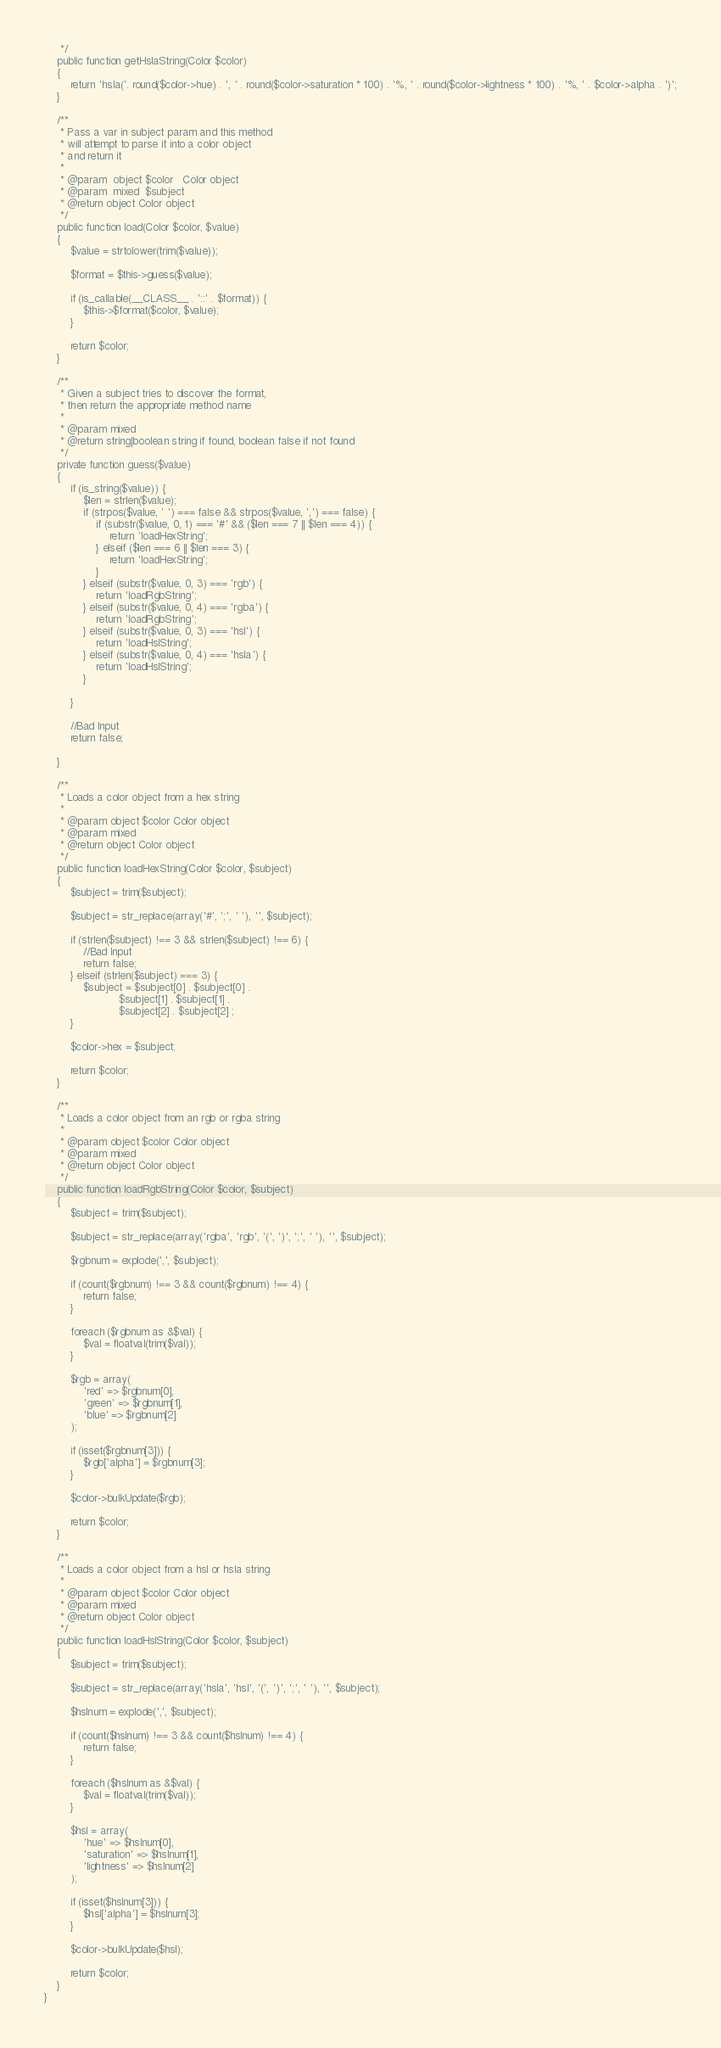Convert code to text. <code><loc_0><loc_0><loc_500><loc_500><_PHP_>     */
    public function getHslaString(Color $color)
    {
        return 'hsla('. round($color->hue) . ', ' . round($color->saturation * 100) . '%, ' . round($color->lightness * 100) . '%, ' . $color->alpha . ')';
    }

    /**
     * Pass a var in subject param and this method
     * will attempt to parse it into a color object
     * and return it
     *
     * @param  object $color   Color object
     * @param  mixed  $subject
     * @return object Color object
     */
    public function load(Color $color, $value)
    {
        $value = strtolower(trim($value));

        $format = $this->guess($value);

        if (is_callable(__CLASS__ . '::' . $format)) {
            $this->$format($color, $value);
        }

        return $color;
    }

    /**
     * Given a subject tries to discover the format,
     * then return the appropriate method name
     *
     * @param mixed
     * @return string|boolean string if found, boolean false if not found
     */
    private function guess($value)
    {
        if (is_string($value)) {
            $len = strlen($value);
            if (strpos($value, ' ') === false && strpos($value, ',') === false) {
                if (substr($value, 0, 1) === '#' && ($len === 7 || $len === 4)) {
                    return 'loadHexString';
                } elseif ($len === 6 || $len === 3) {
                    return 'loadHexString';
                }
            } elseif (substr($value, 0, 3) === 'rgb') {
                return 'loadRgbString';
            } elseif (substr($value, 0, 4) === 'rgba') {
                return 'loadRgbString';
            } elseif (substr($value, 0, 3) === 'hsl') {
                return 'loadHslString';
            } elseif (substr($value, 0, 4) === 'hsla') {
                return 'loadHslString';
            }

        }

        //Bad Input
        return false;

    }

    /**
     * Loads a color object from a hex string
     *
     * @param object $color Color object
     * @param mixed
     * @return object Color object
     */
    public function loadHexString(Color $color, $subject)
    {
        $subject = trim($subject);

        $subject = str_replace(array('#', ';', ' '), '', $subject);

        if (strlen($subject) !== 3 && strlen($subject) !== 6) {
            //Bad Input
            return false;
        } elseif (strlen($subject) === 3) {
            $subject = $subject[0] . $subject[0] .
                       $subject[1] . $subject[1] .
                       $subject[2] . $subject[2] ;
        }

        $color->hex = $subject;

        return $color;
    }

    /**
     * Loads a color object from an rgb or rgba string
     *
     * @param object $color Color object
     * @param mixed
     * @return object Color object
     */
    public function loadRgbString(Color $color, $subject)
    {
        $subject = trim($subject);

        $subject = str_replace(array('rgba', 'rgb', '(', ')', ';', ' '), '', $subject);

        $rgbnum = explode(',', $subject);

        if (count($rgbnum) !== 3 && count($rgbnum) !== 4) {
            return false;
        }

        foreach ($rgbnum as &$val) {
            $val = floatval(trim($val));
        }

        $rgb = array(
            'red' => $rgbnum[0],
            'green' => $rgbnum[1],
            'blue' => $rgbnum[2]
        );

        if (isset($rgbnum[3])) {
            $rgb['alpha'] = $rgbnum[3];
        }

        $color->bulkUpdate($rgb);

        return $color;
    }

    /**
     * Loads a color object from a hsl or hsla string
     *
     * @param object $color Color object
     * @param mixed
     * @return object Color object
     */
    public function loadHslString(Color $color, $subject)
    {
        $subject = trim($subject);

        $subject = str_replace(array('hsla', 'hsl', '(', ')', ';', ' '), '', $subject);

        $hslnum = explode(',', $subject);

        if (count($hslnum) !== 3 && count($hslnum) !== 4) {
            return false;
        }

        foreach ($hslnum as &$val) {
            $val = floatval(trim($val));
        }

        $hsl = array(
            'hue' => $hslnum[0],
            'saturation' => $hslnum[1],
            'lightness' => $hslnum[2]
        );

        if (isset($hslnum[3])) {
            $hsl['alpha'] = $hslnum[3];
        }

        $color->bulkUpdate($hsl);

        return $color;
    }
}
</code> 